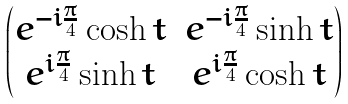Convert formula to latex. <formula><loc_0><loc_0><loc_500><loc_500>\begin{pmatrix} e ^ { - i \frac { \pi } { 4 } } \cosh t & e ^ { - i \frac { \pi } { 4 } } \sinh t \\ e ^ { i \frac { \pi } { 4 } } \sinh t & e ^ { i \frac { \pi } { 4 } } \cosh t \end{pmatrix}</formula> 